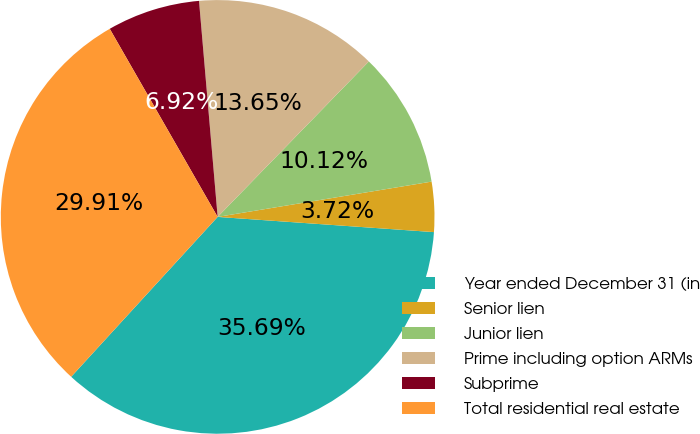Convert chart. <chart><loc_0><loc_0><loc_500><loc_500><pie_chart><fcel>Year ended December 31 (in<fcel>Senior lien<fcel>Junior lien<fcel>Prime including option ARMs<fcel>Subprime<fcel>Total residential real estate<nl><fcel>35.69%<fcel>3.72%<fcel>10.12%<fcel>13.65%<fcel>6.92%<fcel>29.91%<nl></chart> 